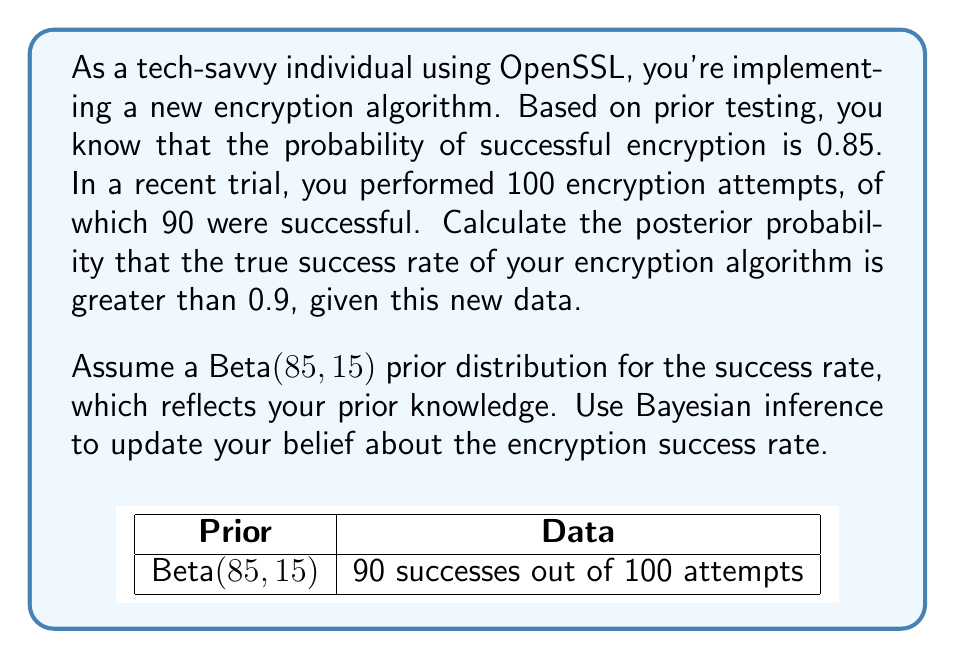Provide a solution to this math problem. Let's approach this step-by-step using Bayesian inference:

1) We start with a Beta(85, 15) prior distribution, which reflects our prior belief about the encryption success rate.

2) We observe 90 successes out of 100 trials. This is our likelihood.

3) The posterior distribution is also a Beta distribution, with parameters:
   $$\alpha_{posterior} = \alpha_{prior} + \text{successes} = 85 + 90 = 175$$
   $$\beta_{posterior} = \beta_{prior} + \text{failures} = 15 + 10 = 25$$

4) So our posterior distribution is Beta(175, 25).

5) We want to find P(θ > 0.9 | data), where θ is the true success rate.

6) This probability is the area under the posterior distribution curve from 0.9 to 1.

7) We can calculate this using the cumulative distribution function (CDF) of the Beta distribution:

   $$P(\theta > 0.9 | \text{data}) = 1 - \text{CDF}_{\text{Beta}(175,25)}(0.9)$$

8) Using a statistical software or calculator (as the calculation is complex), we find:

   $$1 - \text{CDF}_{\text{Beta}(175,25)}(0.9) \approx 0.0103$$

Therefore, the posterior probability that the true success rate is greater than 0.9, given the new data, is approximately 0.0103 or 1.03%.
Answer: 0.0103 